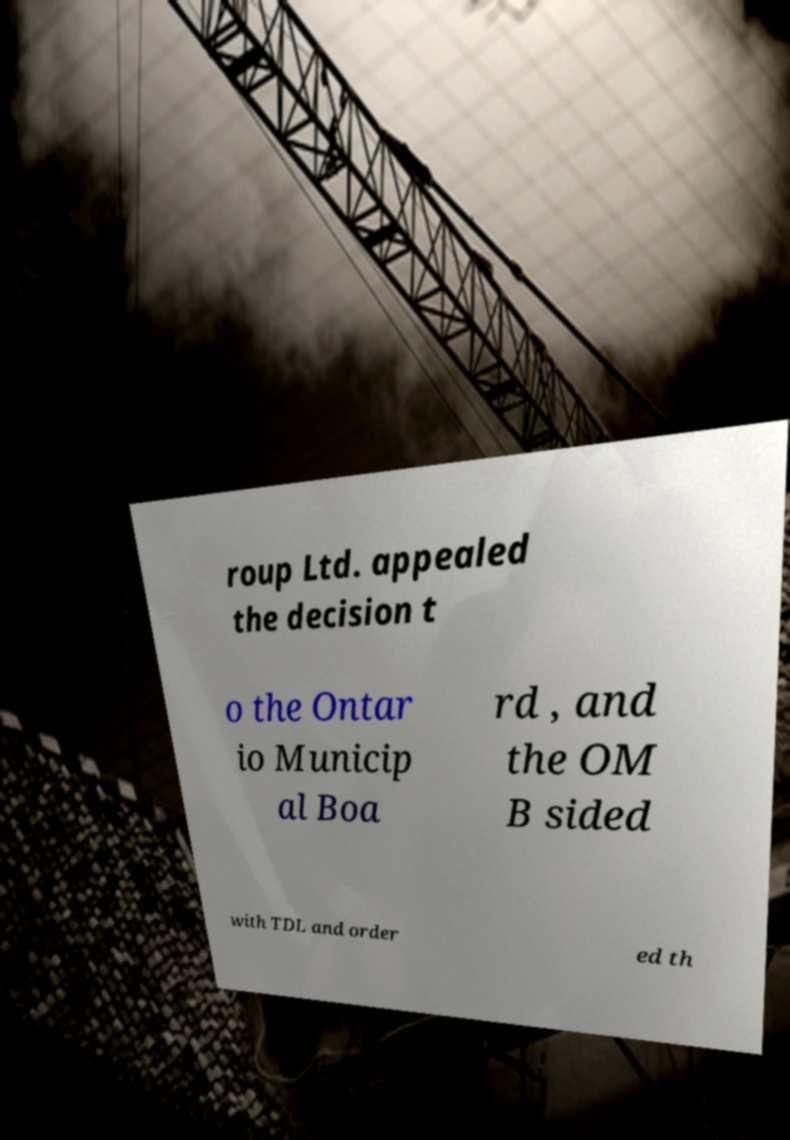Can you read and provide the text displayed in the image?This photo seems to have some interesting text. Can you extract and type it out for me? roup Ltd. appealed the decision t o the Ontar io Municip al Boa rd , and the OM B sided with TDL and order ed th 